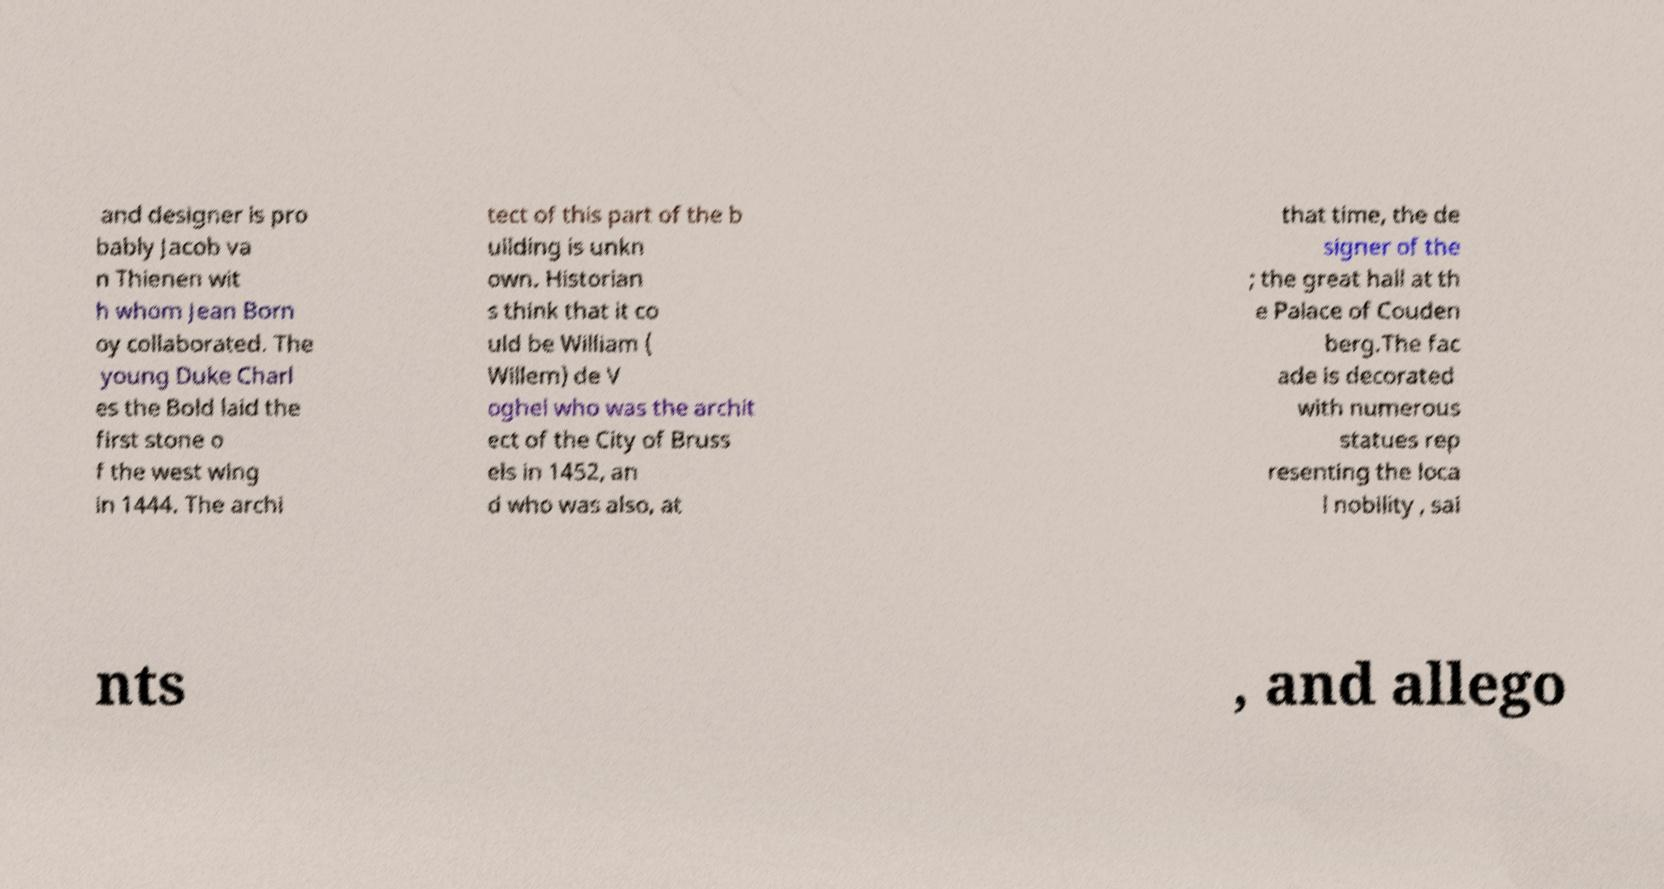Please read and relay the text visible in this image. What does it say? and designer is pro bably Jacob va n Thienen wit h whom Jean Born oy collaborated. The young Duke Charl es the Bold laid the first stone o f the west wing in 1444. The archi tect of this part of the b uilding is unkn own. Historian s think that it co uld be William ( Willem) de V oghel who was the archit ect of the City of Bruss els in 1452, an d who was also, at that time, the de signer of the ; the great hall at th e Palace of Couden berg.The fac ade is decorated with numerous statues rep resenting the loca l nobility , sai nts , and allego 